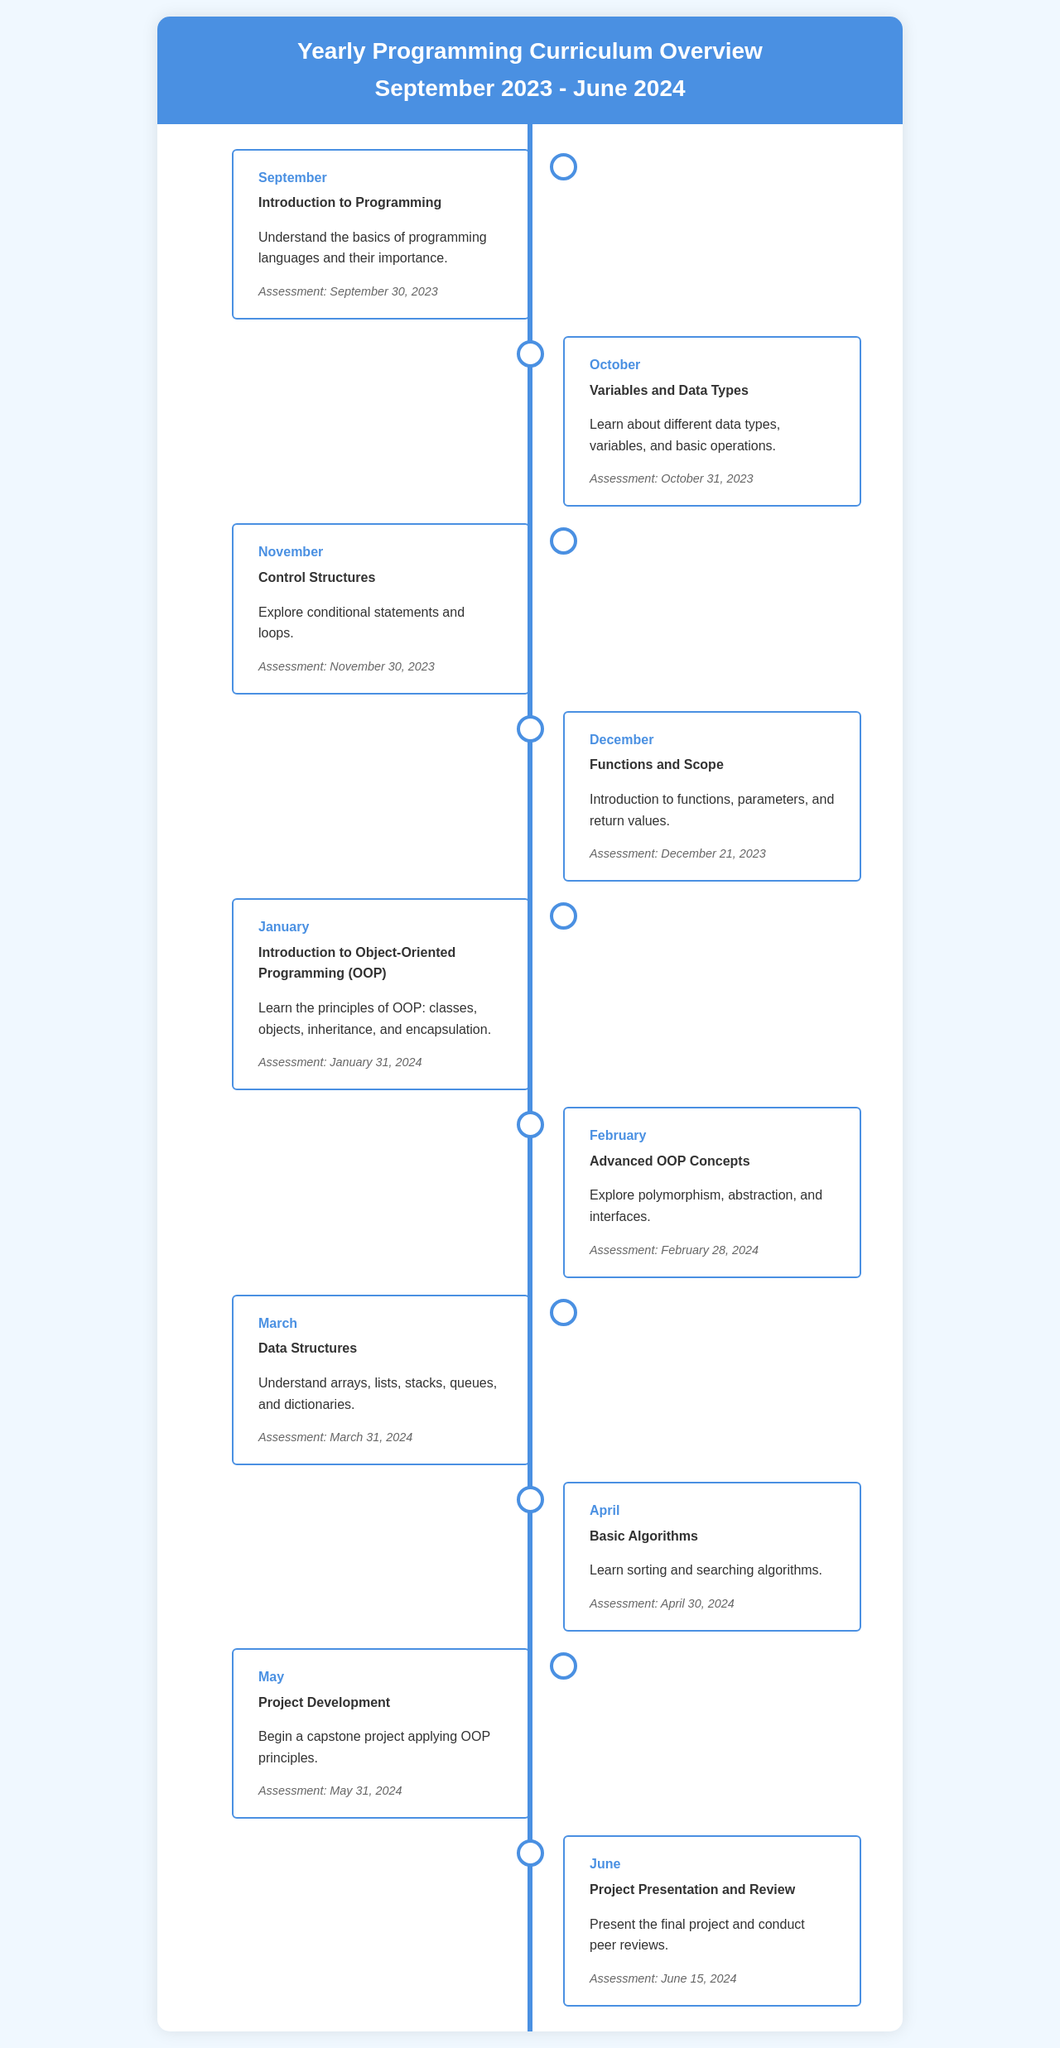What is the first topic covered in September? The first topic listed in September is "Introduction to Programming."
Answer: Introduction to Programming When is the assessment for October? The assessment date for October is explicitly stated in the document.
Answer: October 31, 2023 What key concept is introduced in January? In January, the key concept is "Introduction to Object-Oriented Programming (OOP)."
Answer: Introduction to Object-Oriented Programming Which month focuses on advanced OOP concepts? The document specifies that February covers advanced OOP concepts.
Answer: February How many assessments are scheduled before May? The number of months from September to April, each with an assessment, can be counted.
Answer: Eight What is the last month in the curriculum? The last month mentioned in the curriculum overview is explicitly stated.
Answer: June In what month does project development begin? The document indicates that project development starts in May.
Answer: May What is the assessment date for March? The assessment date for March is provided in the document text.
Answer: March 31, 2024 What is a key topic taught in December? December covers the topic of "Functions and Scope."
Answer: Functions and Scope 